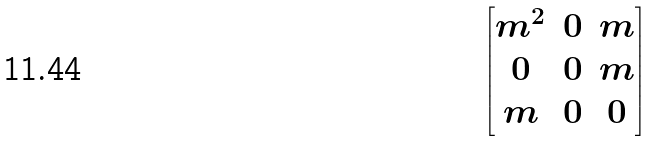<formula> <loc_0><loc_0><loc_500><loc_500>\begin{bmatrix} m ^ { 2 } & 0 & m \\ 0 & 0 & m \\ m & 0 & 0 \\ \end{bmatrix}</formula> 